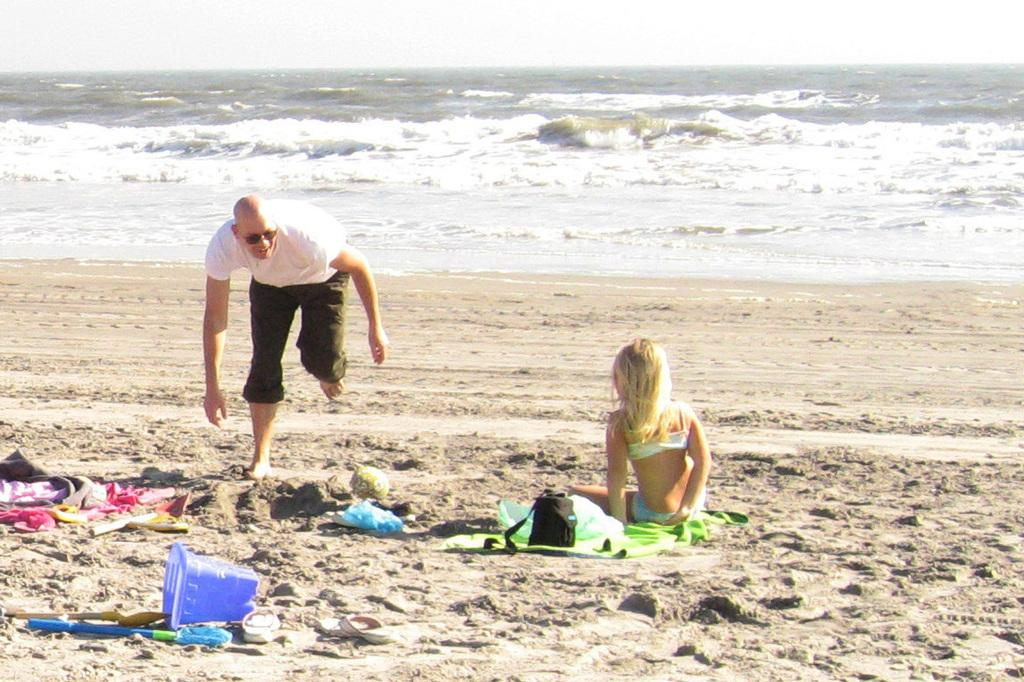Who or what can be seen in the image? There are persons in the image. What else is present in the image besides the persons? There are things in the image. Where is the image set? The image is set at a beach. What is visible at the top of the image? The sky is visible at the top of the image. Where is the market located in the image? There is no market present in the image; it is set at a beach. What type of chair can be seen in the image? There is no chair present in the image. 